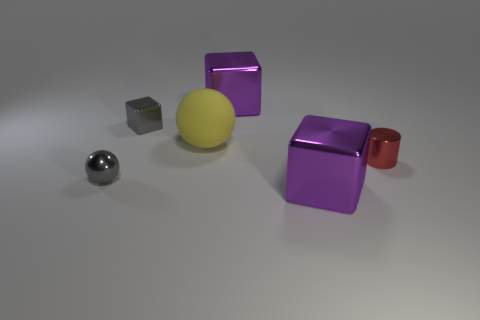Subtract all red cylinders. How many purple blocks are left? 2 Subtract all gray metallic cubes. How many cubes are left? 2 Add 1 shiny spheres. How many objects exist? 7 Subtract all cylinders. How many objects are left? 5 Subtract all shiny cylinders. Subtract all cyan metallic cylinders. How many objects are left? 5 Add 3 small metal balls. How many small metal balls are left? 4 Add 2 matte balls. How many matte balls exist? 3 Subtract 1 red cylinders. How many objects are left? 5 